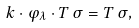<formula> <loc_0><loc_0><loc_500><loc_500>k \cdot \varphi _ { \lambda } \cdot T \, \sigma = T \, \sigma ,</formula> 